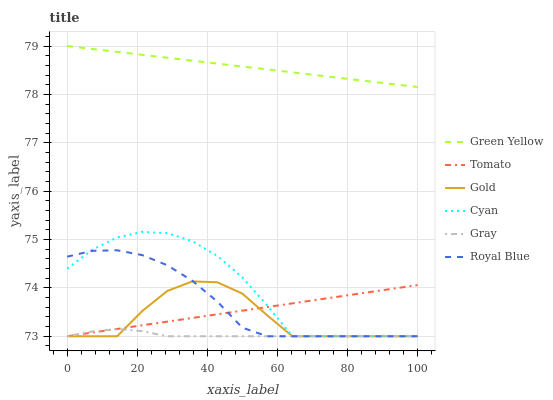Does Gray have the minimum area under the curve?
Answer yes or no. Yes. Does Green Yellow have the maximum area under the curve?
Answer yes or no. Yes. Does Gold have the minimum area under the curve?
Answer yes or no. No. Does Gold have the maximum area under the curve?
Answer yes or no. No. Is Green Yellow the smoothest?
Answer yes or no. Yes. Is Gold the roughest?
Answer yes or no. Yes. Is Gray the smoothest?
Answer yes or no. No. Is Gray the roughest?
Answer yes or no. No. Does Tomato have the lowest value?
Answer yes or no. Yes. Does Green Yellow have the lowest value?
Answer yes or no. No. Does Green Yellow have the highest value?
Answer yes or no. Yes. Does Gold have the highest value?
Answer yes or no. No. Is Cyan less than Green Yellow?
Answer yes or no. Yes. Is Green Yellow greater than Gold?
Answer yes or no. Yes. Does Cyan intersect Gray?
Answer yes or no. Yes. Is Cyan less than Gray?
Answer yes or no. No. Is Cyan greater than Gray?
Answer yes or no. No. Does Cyan intersect Green Yellow?
Answer yes or no. No. 